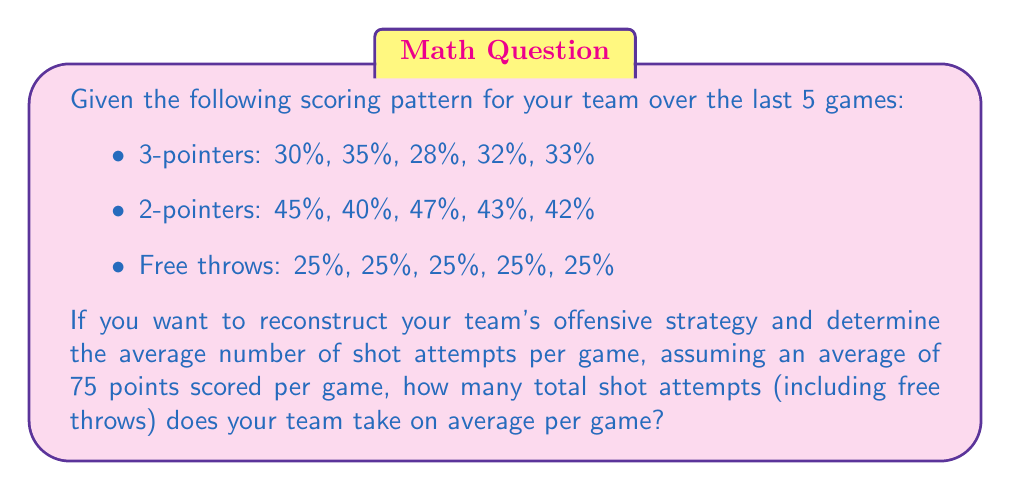Can you answer this question? Let's approach this step-by-step:

1) First, we need to calculate the average percentage for each type of shot:
   3-pointers: $(30 + 35 + 28 + 32 + 33) / 5 = 31.6\%$
   2-pointers: $(45 + 40 + 47 + 43 + 42) / 5 = 43.4\%$
   Free throws: $(25 + 25 + 25 + 25 + 25) / 5 = 25\%$

2) Now, let's define variables:
   Let $x$ be the number of 3-point attempts
   Let $y$ be the number of 2-point attempts
   Let $z$ be the number of free throw attempts

3) We can set up an equation based on the average points scored:
   $$(0.316 \cdot 3x) + (0.434 \cdot 2y) + (0.25 \cdot z) = 75$$

4) We also know that the percentages must add up to 100%:
   $$0.316x + 0.434y + 0.25z = x + y + z$$

5) From this, we can derive:
   $$0.684x + 0.566y = 0.75z$$

6) Substituting this into our points equation:
   $$(0.316 \cdot 3 \cdot \frac{0.75z - 0.566y}{0.684}) + (0.434 \cdot 2y) + (0.25 \cdot z) = 75$$

7) Simplifying:
   $$1.04z - 0.784y + 0.868y + 0.25z = 75$$
   $$1.29z + 0.084y = 75$$

8) We can estimate that $y \approx 2z$ (2-point attempts are usually about twice free throw attempts), so:
   $$1.29z + 0.168z = 75$$
   $$1.458z = 75$$
   $$z \approx 51.44$$

9) Therefore:
   $x \approx 25.72$
   $y \approx 51.44$
   $z \approx 51.44$

10) The total number of shot attempts is the sum of these:
    $$25.72 + 51.44 + 51.44 \approx 128.6$$
Answer: 129 shot attempts 